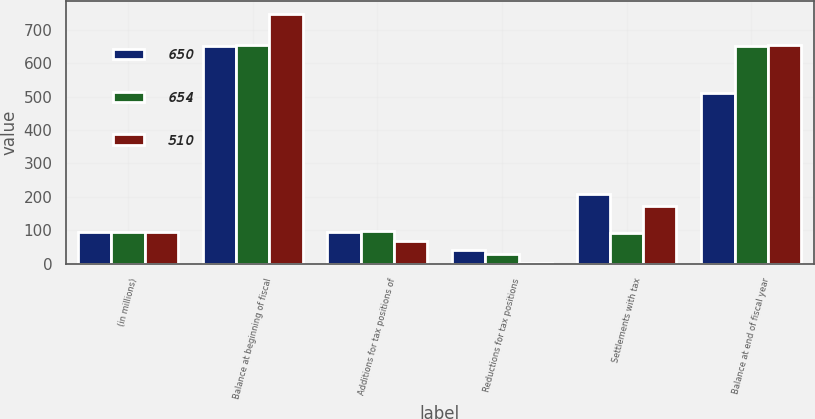Convert chart to OTSL. <chart><loc_0><loc_0><loc_500><loc_500><stacked_bar_chart><ecel><fcel>(in millions)<fcel>Balance at beginning of fiscal<fcel>Additions for tax positions of<fcel>Reductions for tax positions<fcel>Settlements with tax<fcel>Balance at end of fiscal year<nl><fcel>650<fcel>95.5<fcel>650<fcel>94<fcel>40<fcel>210<fcel>510<nl><fcel>654<fcel>95.5<fcel>654<fcel>97<fcel>30<fcel>93<fcel>650<nl><fcel>510<fcel>95.5<fcel>747<fcel>68<fcel>3<fcel>172<fcel>654<nl></chart> 